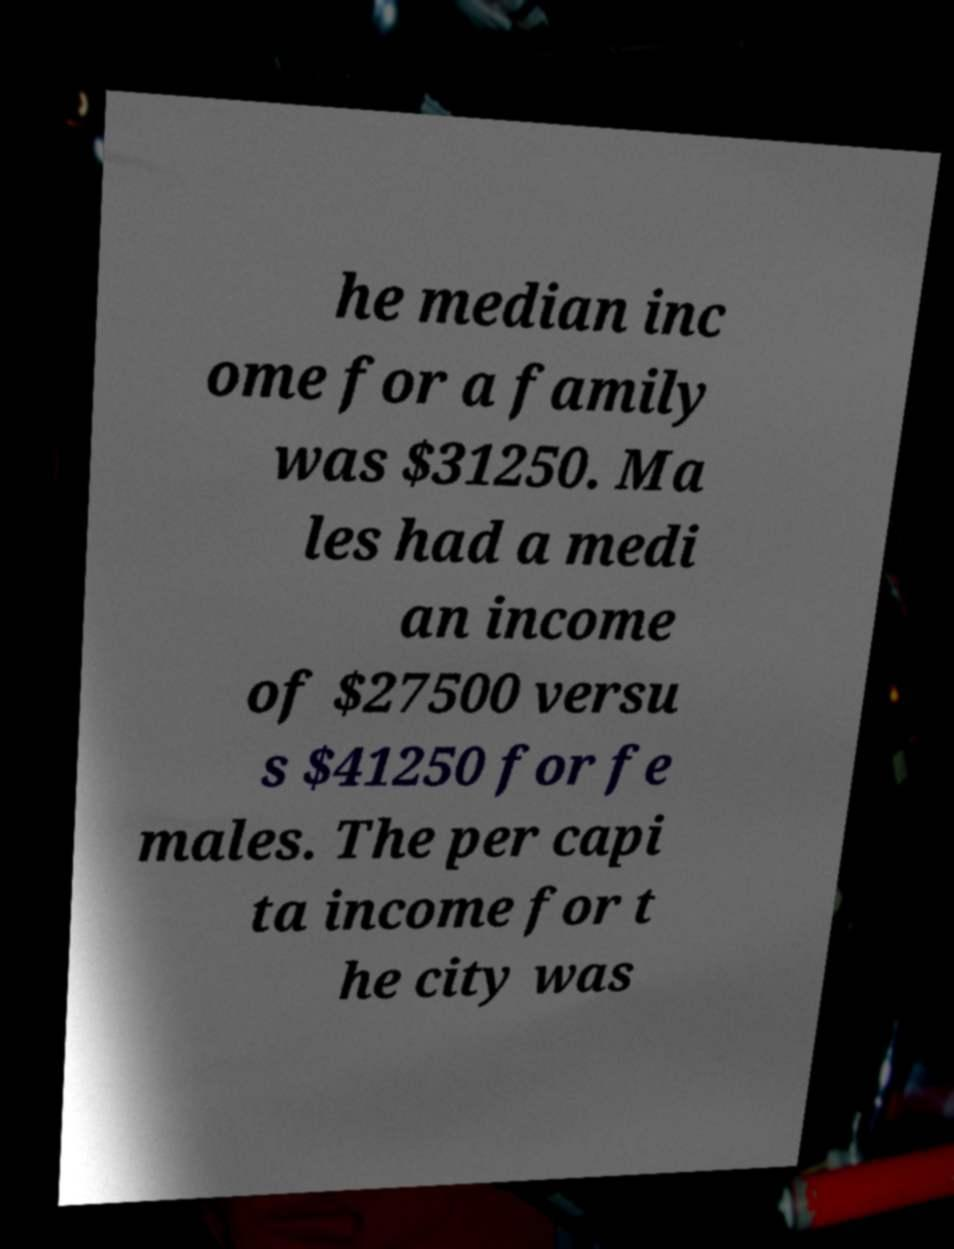For documentation purposes, I need the text within this image transcribed. Could you provide that? he median inc ome for a family was $31250. Ma les had a medi an income of $27500 versu s $41250 for fe males. The per capi ta income for t he city was 